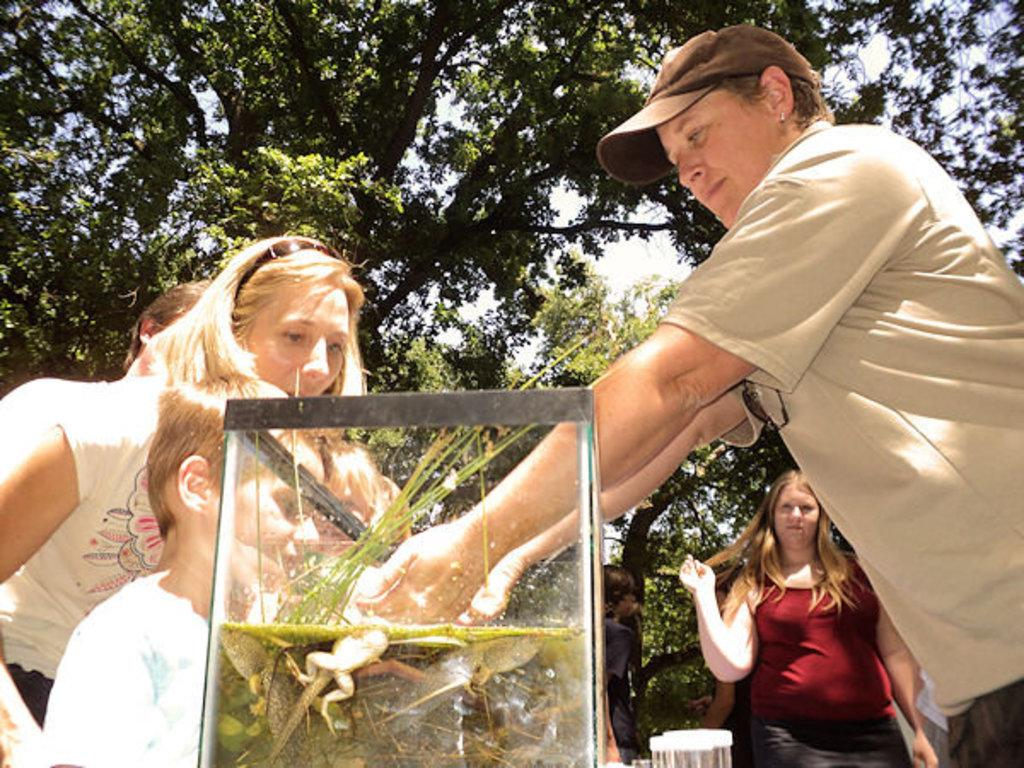What is happening in the image? There are people standing in the image. What can be seen in the water in the image? There is a frog in the water in the image. What type of vegetation is present in the image? There are trees in the image. What type of slope can be seen in the image? There is no slope present in the image. 